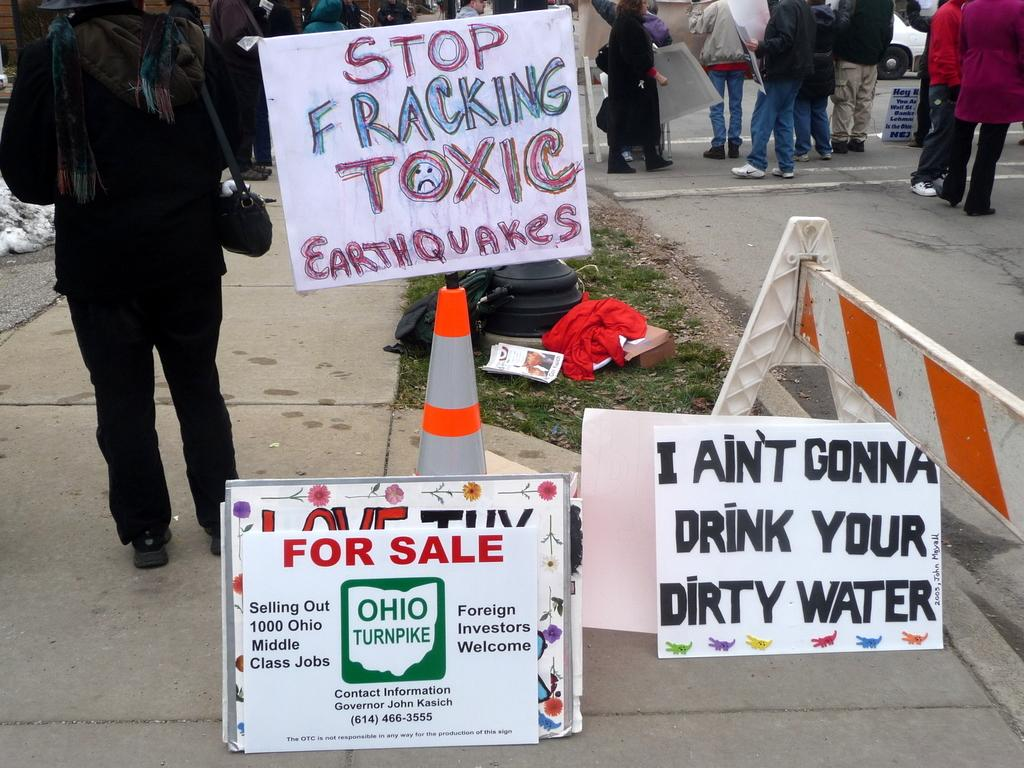What objects are present at the bottom of the image? There are posters present at the bottom of the image. What can be seen in the background of the image? There are people standing in the background of the image. Are there any icicles hanging from the posters in the image? There are no icicles present in the image; it features posters and people standing in the background. What type of comparison can be made between the posters and the cherries in the image? There are no cherries present in the image, so no comparison can be made. 